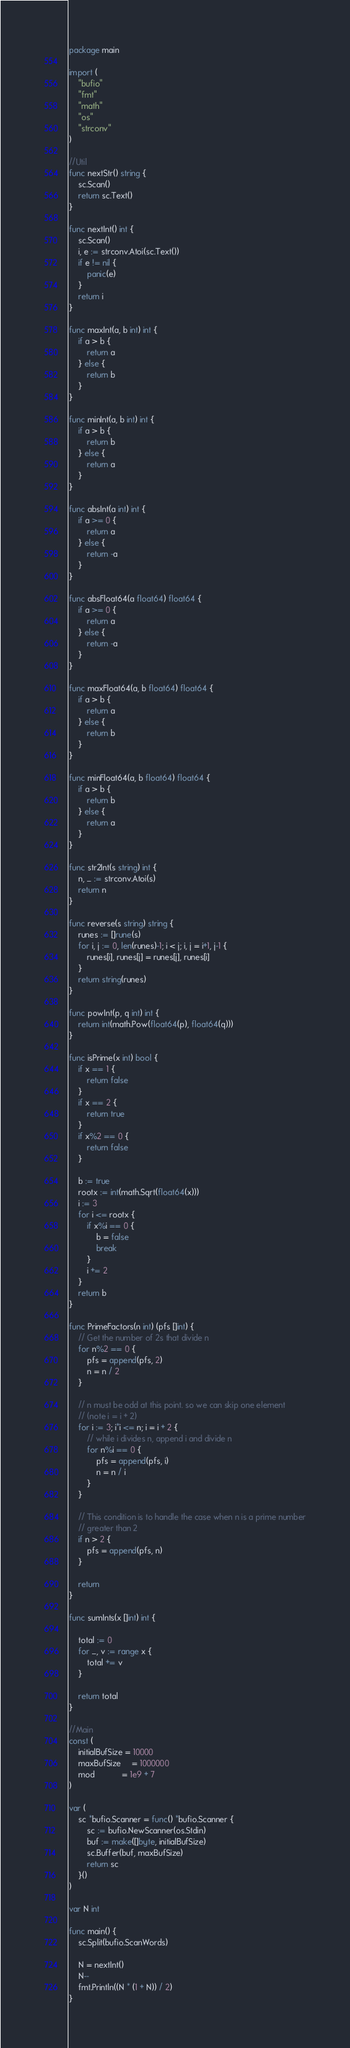<code> <loc_0><loc_0><loc_500><loc_500><_Go_>package main

import (
	"bufio"
	"fmt"
	"math"
	"os"
	"strconv"
)

//Util
func nextStr() string {
	sc.Scan()
	return sc.Text()
}

func nextInt() int {
	sc.Scan()
	i, e := strconv.Atoi(sc.Text())
	if e != nil {
		panic(e)
	}
	return i
}

func maxInt(a, b int) int {
	if a > b {
		return a
	} else {
		return b
	}
}

func minInt(a, b int) int {
	if a > b {
		return b
	} else {
		return a
	}
}

func absInt(a int) int {
	if a >= 0 {
		return a
	} else {
		return -a
	}
}

func absFloat64(a float64) float64 {
	if a >= 0 {
		return a
	} else {
		return -a
	}
}

func maxFloat64(a, b float64) float64 {
	if a > b {
		return a
	} else {
		return b
	}
}

func minFloat64(a, b float64) float64 {
	if a > b {
		return b
	} else {
		return a
	}
}

func str2Int(s string) int {
	n, _ := strconv.Atoi(s)
	return n
}

func reverse(s string) string {
	runes := []rune(s)
	for i, j := 0, len(runes)-1; i < j; i, j = i+1, j-1 {
		runes[i], runes[j] = runes[j], runes[i]
	}
	return string(runes)
}

func powInt(p, q int) int {
	return int(math.Pow(float64(p), float64(q)))
}

func isPrime(x int) bool {
	if x == 1 {
		return false
	}
	if x == 2 {
		return true
	}
	if x%2 == 0 {
		return false
	}

	b := true
	rootx := int(math.Sqrt(float64(x)))
	i := 3
	for i <= rootx {
		if x%i == 0 {
			b = false
			break
		}
		i += 2
	}
	return b
}

func PrimeFactors(n int) (pfs []int) {
	// Get the number of 2s that divide n
	for n%2 == 0 {
		pfs = append(pfs, 2)
		n = n / 2
	}

	// n must be odd at this point. so we can skip one element
	// (note i = i + 2)
	for i := 3; i*i <= n; i = i + 2 {
		// while i divides n, append i and divide n
		for n%i == 0 {
			pfs = append(pfs, i)
			n = n / i
		}
	}

	// This condition is to handle the case when n is a prime number
	// greater than 2
	if n > 2 {
		pfs = append(pfs, n)
	}

	return
}

func sumInts(x []int) int {

	total := 0
	for _, v := range x {
		total += v
	}

	return total
}

//Main
const (
	initialBufSize = 10000
	maxBufSize     = 1000000
	mod            = 1e9 + 7
)

var (
	sc *bufio.Scanner = func() *bufio.Scanner {
		sc := bufio.NewScanner(os.Stdin)
		buf := make([]byte, initialBufSize)
		sc.Buffer(buf, maxBufSize)
		return sc
	}()
)

var N int

func main() {
	sc.Split(bufio.ScanWords)

	N = nextInt()
	N--
	fmt.Println((N * (1 + N)) / 2)
}
</code> 